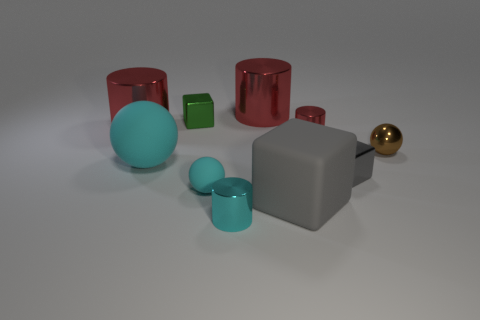Subtract all gray blocks. How many were subtracted if there are1gray blocks left? 1 Subtract all green blocks. How many red cylinders are left? 3 Subtract 1 spheres. How many spheres are left? 2 Subtract all big gray matte cubes. How many cubes are left? 2 Subtract all cyan cylinders. How many cylinders are left? 3 Subtract all gray cylinders. Subtract all yellow spheres. How many cylinders are left? 4 Subtract all cylinders. How many objects are left? 6 Subtract all big cyan balls. Subtract all tiny cyan cylinders. How many objects are left? 8 Add 6 tiny red metallic cylinders. How many tiny red metallic cylinders are left? 7 Add 4 small cyan metallic objects. How many small cyan metallic objects exist? 5 